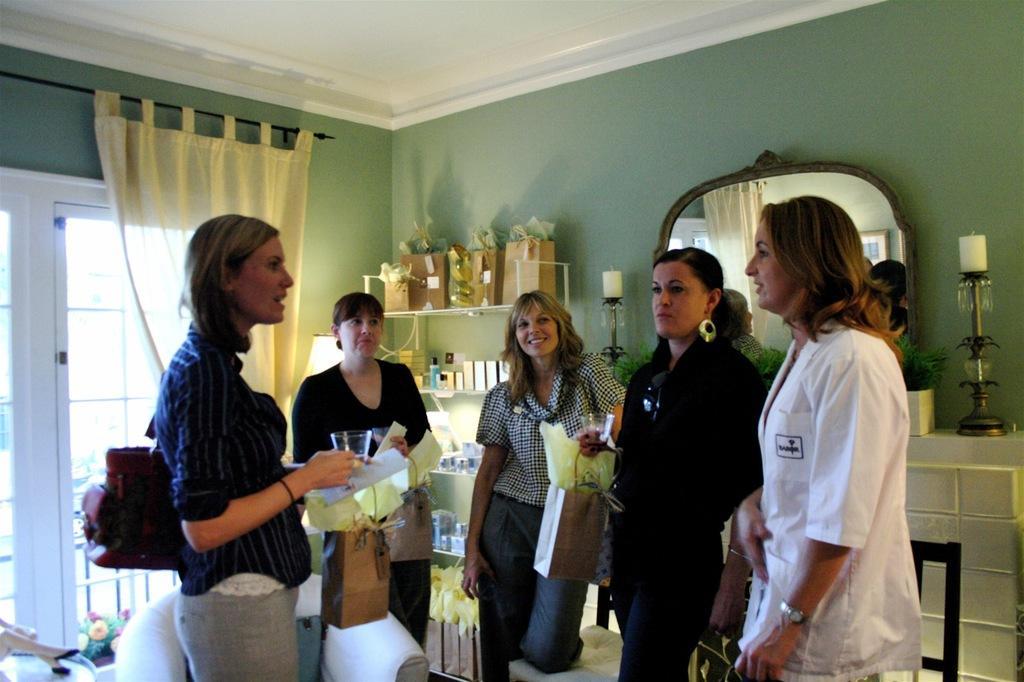Please provide a concise description of this image. In this image we can see women standing on the floor by holding paper bags and glass tumblers in their hands. In the background we can see curtain, windows, paper bags, candle holders, mirror and walls. 